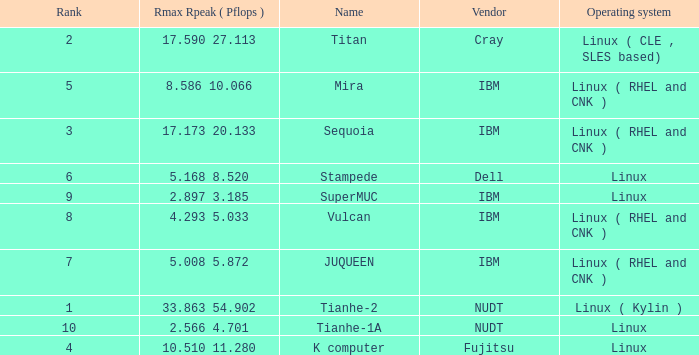What is the name of Rank 5? Mira. 